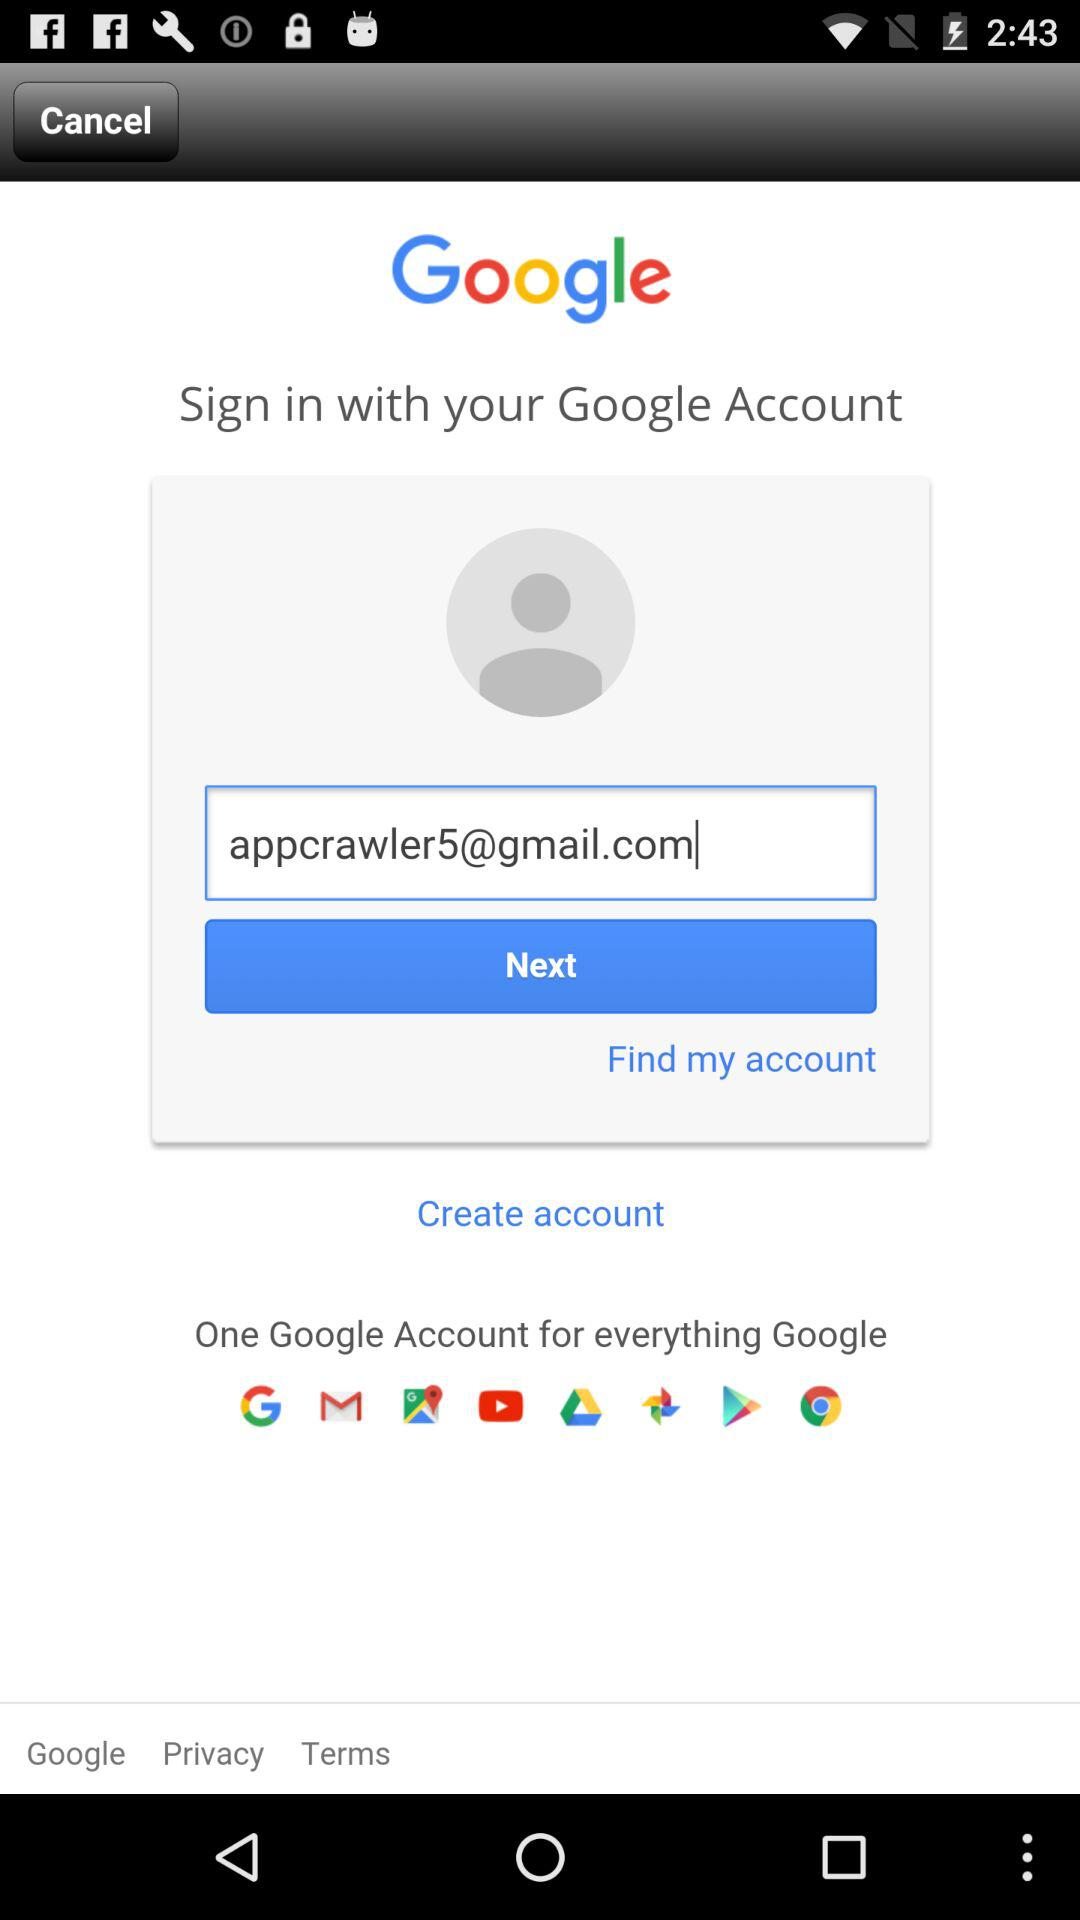What is the email address? The email address is "appcrawler5@gmail.com". 